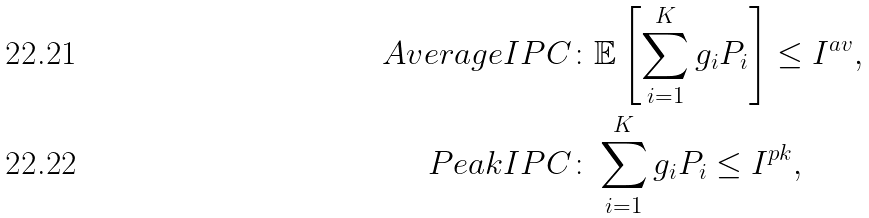Convert formula to latex. <formula><loc_0><loc_0><loc_500><loc_500>A v e r a g e I P C \colon & \mathbb { E } \left [ \sum _ { i = 1 } ^ { K } g _ { i } P _ { i } \right ] \leq I ^ { a v } , \\ P e a k I P C \colon & \sum _ { i = 1 } ^ { K } g _ { i } P _ { i } \leq I ^ { p k } ,</formula> 